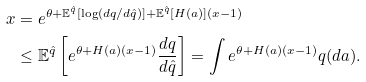<formula> <loc_0><loc_0><loc_500><loc_500>x & = e ^ { \theta + \mathbb { E } ^ { \hat { q } } [ \log ( d q / d \hat { q } ) ] + \mathbb { E } ^ { \hat { q } } [ H ( a ) ] ( x - 1 ) } \\ & \leq \mathbb { E } ^ { \hat { q } } \left [ e ^ { \theta + H ( a ) ( x - 1 ) } \frac { d q } { d \hat { q } } \right ] = \int e ^ { \theta + H ( a ) ( x - 1 ) } q ( d a ) .</formula> 